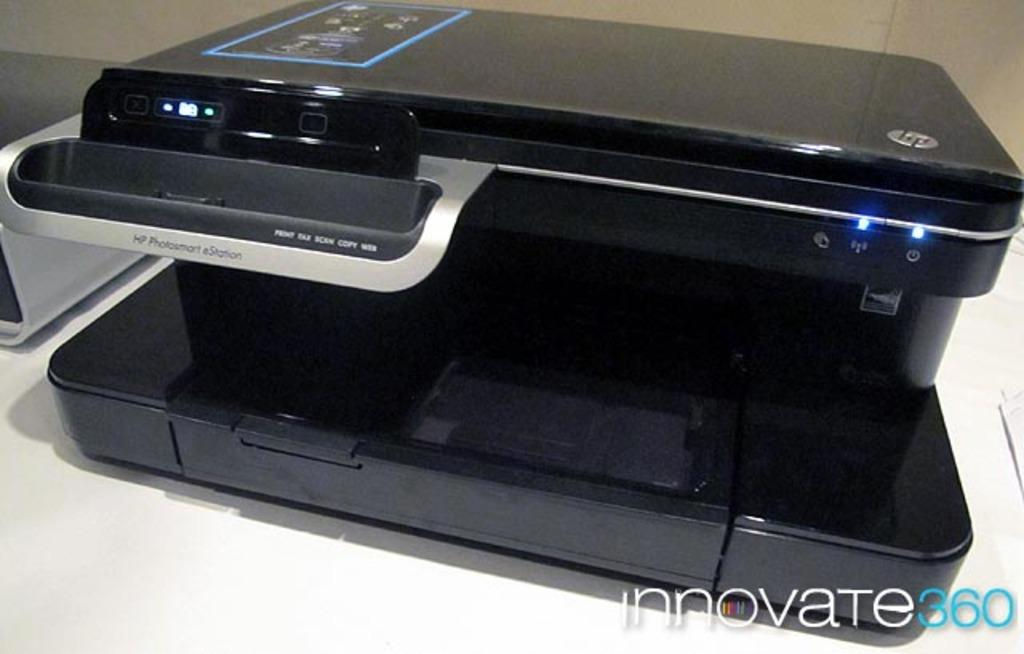What type of device is visible in the image? There is a printer in the image. How many quarters are needed to power the printer in the image? There is no information about quarters or powering the printer in the image, as it only shows the printer itself. 